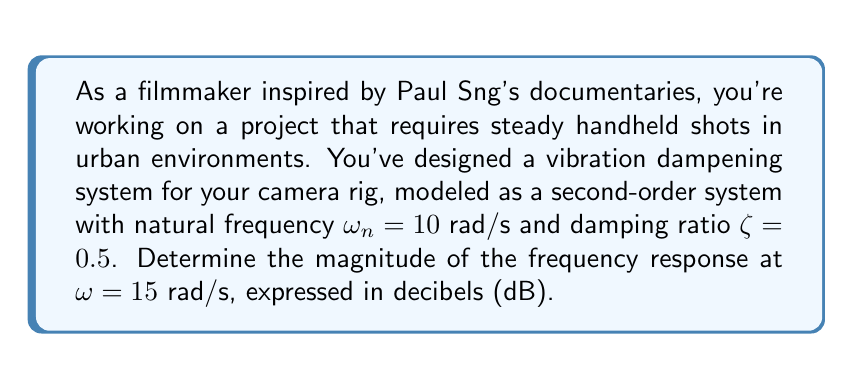Can you solve this math problem? To solve this problem, we'll follow these steps:

1) The transfer function of a second-order system is given by:

   $$G(s) = \frac{\omega_n^2}{s^2 + 2\zeta\omega_n s + \omega_n^2}$$

2) To find the frequency response, we substitute $s$ with $j\omega$:

   $$G(j\omega) = \frac{\omega_n^2}{(j\omega)^2 + 2\zeta\omega_n (j\omega) + \omega_n^2}$$

3) The magnitude of the frequency response is:

   $$|G(j\omega)| = \frac{\omega_n^2}{\sqrt{(\omega_n^2 - \omega^2)^2 + (2\zeta\omega_n\omega)^2}}$$

4) Substituting the given values:
   $\omega_n = 10$ rad/s
   $\zeta = 0.5$
   $\omega = 15$ rad/s

   $$|G(j15)| = \frac{10^2}{\sqrt{(10^2 - 15^2)^2 + (2 \cdot 0.5 \cdot 10 \cdot 15)^2}}$$

5) Simplify:

   $$|G(j15)| = \frac{100}{\sqrt{(-125)^2 + 150^2}} = \frac{100}{\sqrt{15625 + 22500}} = \frac{100}{\sqrt{38125}} \approx 0.5115$$

6) Convert to decibels:

   $$20 \log_{10}(|G(j15)|) = 20 \log_{10}(0.5115) \approx -5.82 \text{ dB}$$
Answer: The magnitude of the frequency response at $\omega = 15$ rad/s is approximately $-5.82$ dB. 